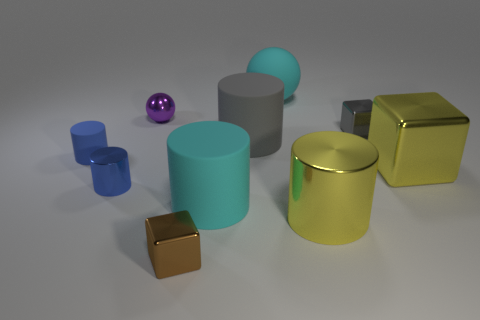Subtract all large yellow metallic cylinders. How many cylinders are left? 4 Subtract all cyan cylinders. How many cylinders are left? 4 Subtract all brown cylinders. Subtract all purple cubes. How many cylinders are left? 5 Subtract all spheres. How many objects are left? 8 Subtract 0 red spheres. How many objects are left? 10 Subtract all tiny blue metal cylinders. Subtract all small blue rubber cylinders. How many objects are left? 8 Add 6 rubber things. How many rubber things are left? 10 Add 8 small purple objects. How many small purple objects exist? 9 